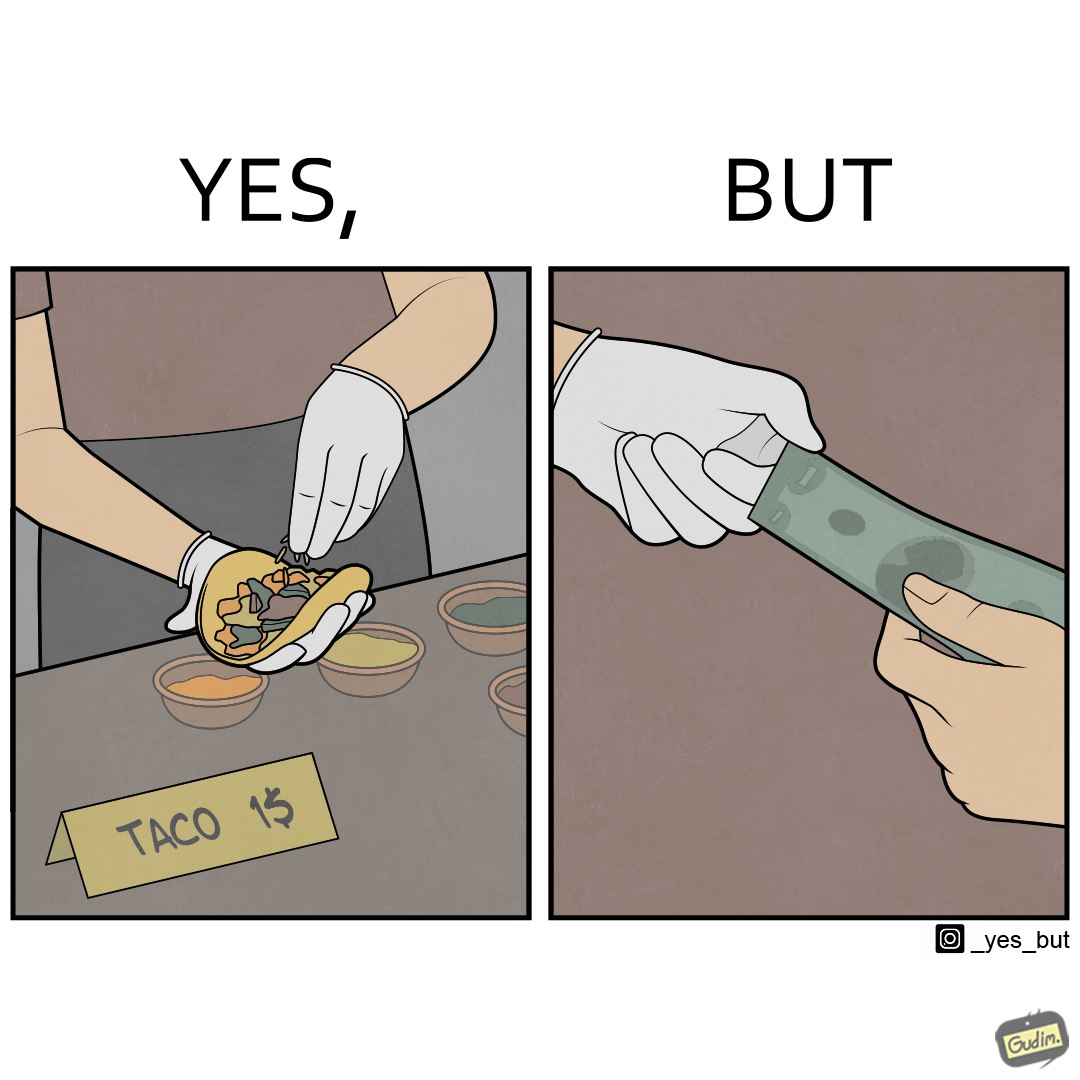Compare the left and right sides of this image. In the left part of the image: The image shows a person wearing white gloves preparing a taco in their hand. There are several condiments on the table. There is also a note that says "TACO 1$" indicating that each taco is sold for only $1. In the right part of the image: The image shows two people transacting $1 among them. One of them is wearing white gloves and one of them is not wearing any gloves. 